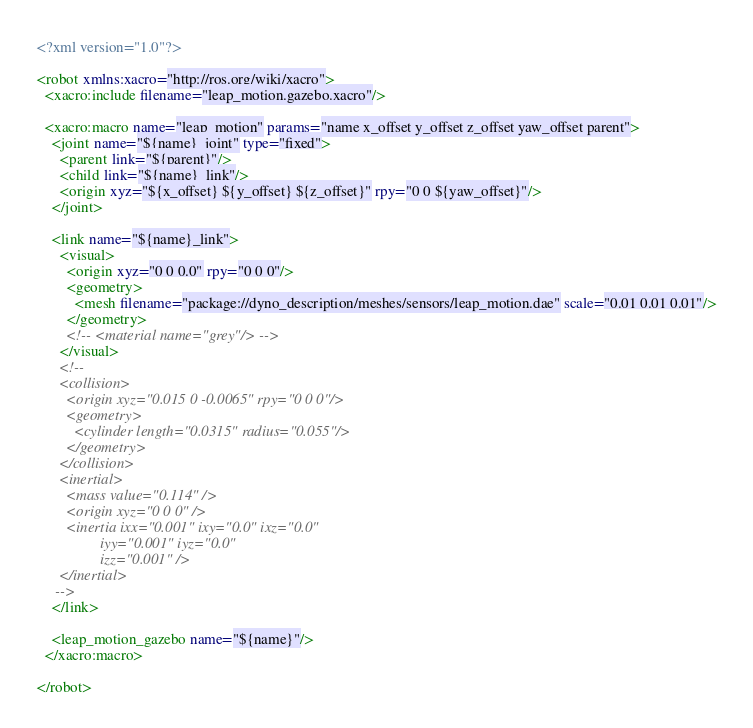<code> <loc_0><loc_0><loc_500><loc_500><_XML_><?xml version="1.0"?>

<robot xmlns:xacro="http://ros.org/wiki/xacro">
  <xacro:include filename="leap_motion.gazebo.xacro"/>

  <xacro:macro name="leap_motion" params="name x_offset y_offset z_offset yaw_offset parent">
    <joint name="${name}_joint" type="fixed">
      <parent link="${parent}"/>
      <child link="${name}_link"/>
      <origin xyz="${x_offset} ${y_offset} ${z_offset}" rpy="0 0 ${yaw_offset}"/>
    </joint>

    <link name="${name}_link">
      <visual>
        <origin xyz="0 0 0.0" rpy="0 0 0"/>
        <geometry>
          <mesh filename="package://dyno_description/meshes/sensors/leap_motion.dae" scale="0.01 0.01 0.01"/>
        </geometry>
        <!-- <material name="grey"/> -->
      </visual>
      <!--
      <collision>
        <origin xyz="0.015 0 -0.0065" rpy="0 0 0"/>
        <geometry>
          <cylinder length="0.0315" radius="0.055"/>
        </geometry>
      </collision>
      <inertial>
        <mass value="0.114" />
        <origin xyz="0 0 0" />
        <inertia ixx="0.001" ixy="0.0" ixz="0.0"
                 iyy="0.001" iyz="0.0"
                 izz="0.001" />
      </inertial>
     -->
    </link>

    <leap_motion_gazebo name="${name}"/>
  </xacro:macro>

</robot>
</code> 